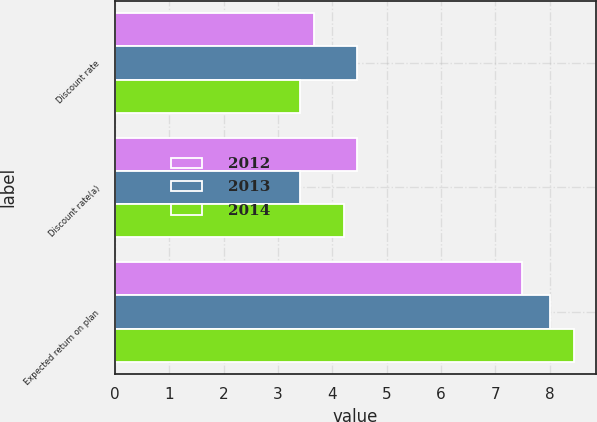Convert chart to OTSL. <chart><loc_0><loc_0><loc_500><loc_500><stacked_bar_chart><ecel><fcel>Discount rate<fcel>Discount rate(a)<fcel>Expected return on plan<nl><fcel>2012<fcel>3.66<fcel>4.45<fcel>7.5<nl><fcel>2013<fcel>4.45<fcel>3.4<fcel>8<nl><fcel>2014<fcel>3.4<fcel>4.22<fcel>8.44<nl></chart> 